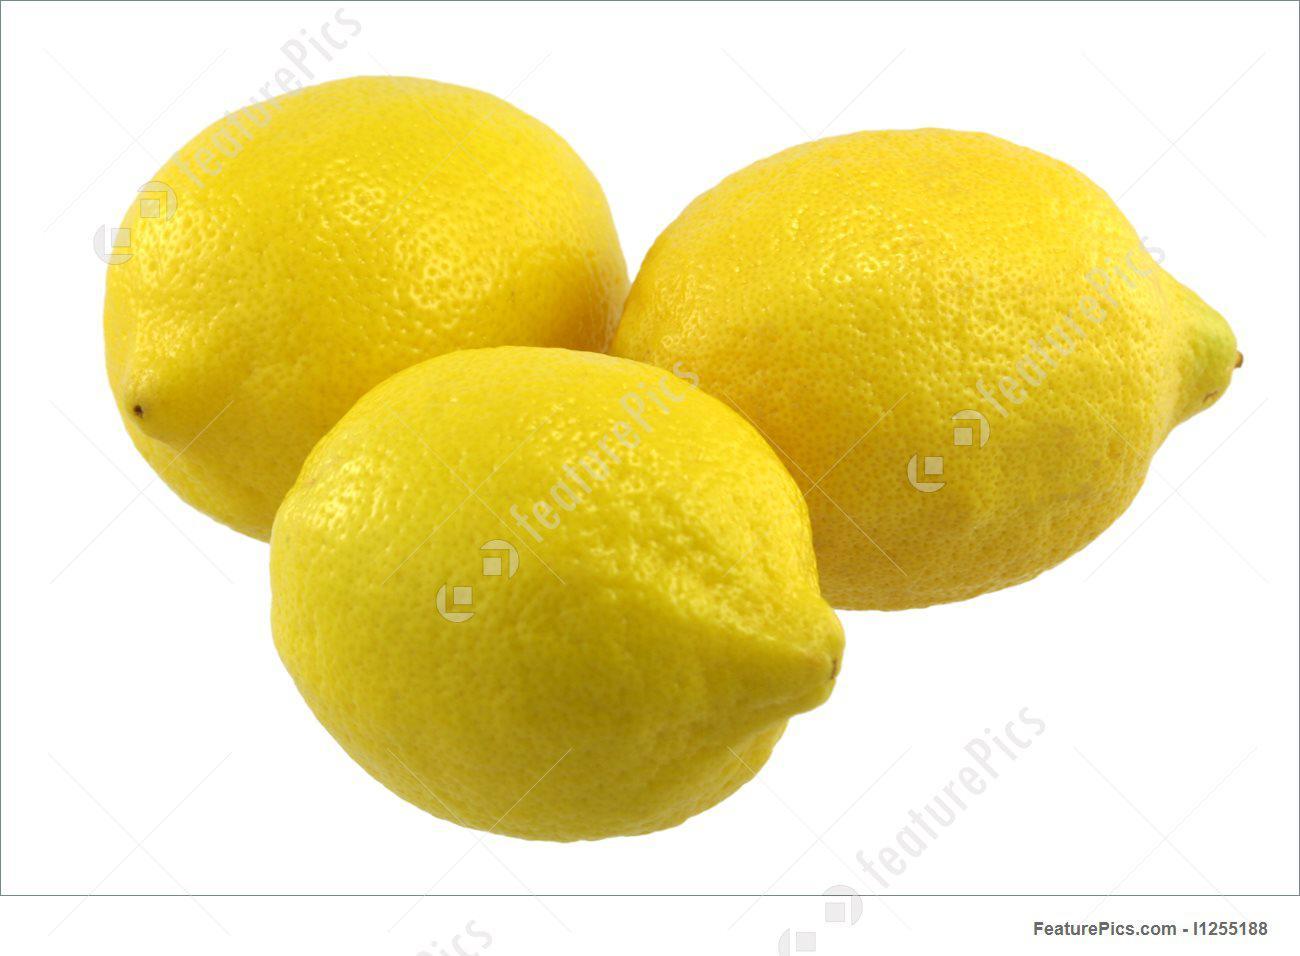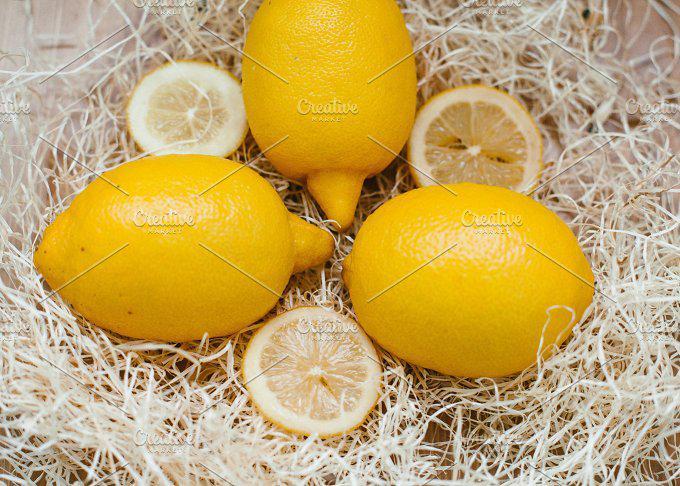The first image is the image on the left, the second image is the image on the right. Considering the images on both sides, is "In one image, some lemons are cut, in the other, none of the lemons are cut." valid? Answer yes or no. Yes. The first image is the image on the left, the second image is the image on the right. Considering the images on both sides, is "In one image there is a combination of sliced and whole lemons, and in the other image there are three whole lemons" valid? Answer yes or no. Yes. 